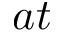<formula> <loc_0><loc_0><loc_500><loc_500>a t</formula> 